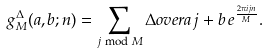<formula> <loc_0><loc_0><loc_500><loc_500>g _ { M } ^ { \Delta } ( a , b ; n ) = \sum _ { j \bmod M } \Delta o v e r { a j + b } \, e ^ { \frac { 2 \pi i j n } { M } } .</formula> 